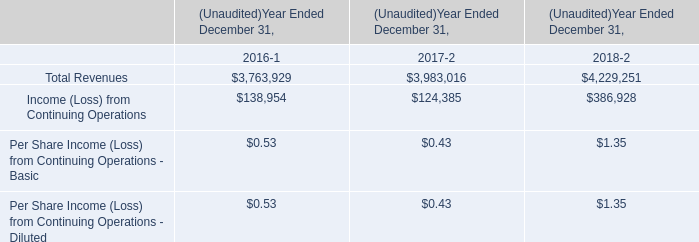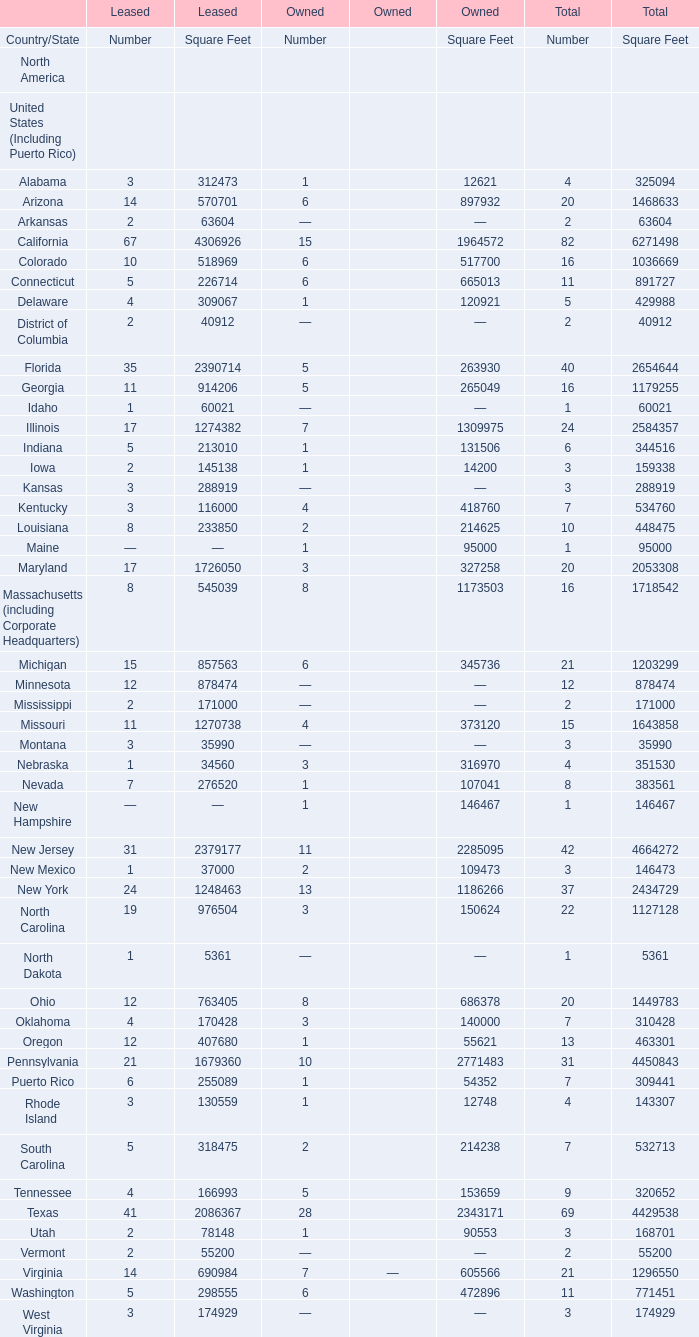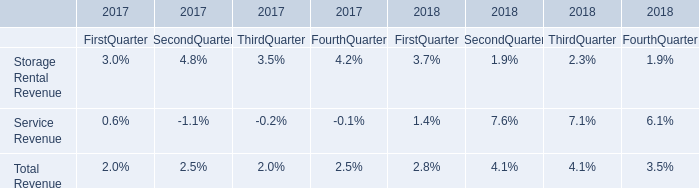What is the ratio of all elements that are in the range of 4000000 and 5000000 to the sum of elements for Square Feet of Total? 
Computations: ((((4664272 + 4450843) + 4429538) + 4995129) / 56040880)
Answer: 0.33083. 